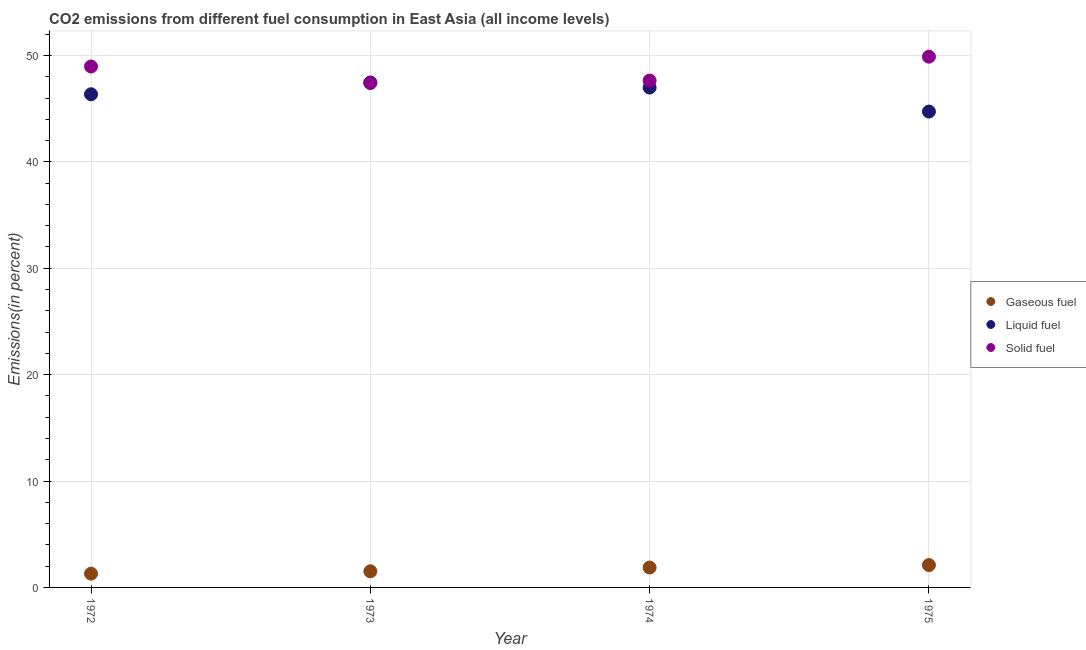How many different coloured dotlines are there?
Your response must be concise. 3. Is the number of dotlines equal to the number of legend labels?
Your answer should be compact. Yes. What is the percentage of gaseous fuel emission in 1973?
Provide a short and direct response. 1.52. Across all years, what is the maximum percentage of gaseous fuel emission?
Keep it short and to the point. 2.1. Across all years, what is the minimum percentage of liquid fuel emission?
Ensure brevity in your answer.  44.73. In which year was the percentage of liquid fuel emission maximum?
Give a very brief answer. 1973. In which year was the percentage of liquid fuel emission minimum?
Offer a terse response. 1975. What is the total percentage of gaseous fuel emission in the graph?
Offer a terse response. 6.79. What is the difference between the percentage of solid fuel emission in 1972 and that in 1974?
Your answer should be very brief. 1.33. What is the difference between the percentage of solid fuel emission in 1974 and the percentage of gaseous fuel emission in 1973?
Give a very brief answer. 46.12. What is the average percentage of gaseous fuel emission per year?
Your answer should be very brief. 1.7. In the year 1974, what is the difference between the percentage of gaseous fuel emission and percentage of liquid fuel emission?
Keep it short and to the point. -45.11. In how many years, is the percentage of gaseous fuel emission greater than 12 %?
Provide a succinct answer. 0. What is the ratio of the percentage of solid fuel emission in 1972 to that in 1975?
Ensure brevity in your answer.  0.98. What is the difference between the highest and the second highest percentage of solid fuel emission?
Offer a terse response. 0.92. What is the difference between the highest and the lowest percentage of liquid fuel emission?
Your answer should be very brief. 2.73. In how many years, is the percentage of solid fuel emission greater than the average percentage of solid fuel emission taken over all years?
Make the answer very short. 2. Does the percentage of liquid fuel emission monotonically increase over the years?
Keep it short and to the point. No. How many dotlines are there?
Your response must be concise. 3. How many years are there in the graph?
Provide a short and direct response. 4. What is the difference between two consecutive major ticks on the Y-axis?
Your response must be concise. 10. Does the graph contain any zero values?
Provide a succinct answer. No. Does the graph contain grids?
Keep it short and to the point. Yes. What is the title of the graph?
Give a very brief answer. CO2 emissions from different fuel consumption in East Asia (all income levels). Does "Transport equipments" appear as one of the legend labels in the graph?
Your response must be concise. No. What is the label or title of the X-axis?
Offer a terse response. Year. What is the label or title of the Y-axis?
Offer a terse response. Emissions(in percent). What is the Emissions(in percent) in Gaseous fuel in 1972?
Keep it short and to the point. 1.3. What is the Emissions(in percent) of Liquid fuel in 1972?
Keep it short and to the point. 46.35. What is the Emissions(in percent) of Solid fuel in 1972?
Offer a terse response. 48.96. What is the Emissions(in percent) in Gaseous fuel in 1973?
Your answer should be compact. 1.52. What is the Emissions(in percent) in Liquid fuel in 1973?
Your answer should be very brief. 47.46. What is the Emissions(in percent) in Solid fuel in 1973?
Ensure brevity in your answer.  47.41. What is the Emissions(in percent) of Gaseous fuel in 1974?
Offer a very short reply. 1.87. What is the Emissions(in percent) of Liquid fuel in 1974?
Your answer should be very brief. 46.98. What is the Emissions(in percent) in Solid fuel in 1974?
Keep it short and to the point. 47.64. What is the Emissions(in percent) of Gaseous fuel in 1975?
Your answer should be compact. 2.1. What is the Emissions(in percent) of Liquid fuel in 1975?
Give a very brief answer. 44.73. What is the Emissions(in percent) in Solid fuel in 1975?
Provide a short and direct response. 49.89. Across all years, what is the maximum Emissions(in percent) in Gaseous fuel?
Your response must be concise. 2.1. Across all years, what is the maximum Emissions(in percent) of Liquid fuel?
Your response must be concise. 47.46. Across all years, what is the maximum Emissions(in percent) in Solid fuel?
Offer a very short reply. 49.89. Across all years, what is the minimum Emissions(in percent) of Gaseous fuel?
Ensure brevity in your answer.  1.3. Across all years, what is the minimum Emissions(in percent) of Liquid fuel?
Provide a short and direct response. 44.73. Across all years, what is the minimum Emissions(in percent) of Solid fuel?
Give a very brief answer. 47.41. What is the total Emissions(in percent) of Gaseous fuel in the graph?
Make the answer very short. 6.79. What is the total Emissions(in percent) in Liquid fuel in the graph?
Ensure brevity in your answer.  185.52. What is the total Emissions(in percent) of Solid fuel in the graph?
Your response must be concise. 193.9. What is the difference between the Emissions(in percent) of Gaseous fuel in 1972 and that in 1973?
Your answer should be compact. -0.22. What is the difference between the Emissions(in percent) of Liquid fuel in 1972 and that in 1973?
Provide a succinct answer. -1.1. What is the difference between the Emissions(in percent) of Solid fuel in 1972 and that in 1973?
Give a very brief answer. 1.55. What is the difference between the Emissions(in percent) of Gaseous fuel in 1972 and that in 1974?
Offer a terse response. -0.57. What is the difference between the Emissions(in percent) of Liquid fuel in 1972 and that in 1974?
Keep it short and to the point. -0.63. What is the difference between the Emissions(in percent) in Solid fuel in 1972 and that in 1974?
Offer a very short reply. 1.33. What is the difference between the Emissions(in percent) of Gaseous fuel in 1972 and that in 1975?
Your response must be concise. -0.81. What is the difference between the Emissions(in percent) in Liquid fuel in 1972 and that in 1975?
Provide a succinct answer. 1.63. What is the difference between the Emissions(in percent) of Solid fuel in 1972 and that in 1975?
Provide a succinct answer. -0.92. What is the difference between the Emissions(in percent) in Gaseous fuel in 1973 and that in 1974?
Your answer should be compact. -0.36. What is the difference between the Emissions(in percent) of Liquid fuel in 1973 and that in 1974?
Provide a succinct answer. 0.48. What is the difference between the Emissions(in percent) in Solid fuel in 1973 and that in 1974?
Provide a short and direct response. -0.23. What is the difference between the Emissions(in percent) in Gaseous fuel in 1973 and that in 1975?
Make the answer very short. -0.59. What is the difference between the Emissions(in percent) of Liquid fuel in 1973 and that in 1975?
Make the answer very short. 2.73. What is the difference between the Emissions(in percent) of Solid fuel in 1973 and that in 1975?
Give a very brief answer. -2.48. What is the difference between the Emissions(in percent) of Gaseous fuel in 1974 and that in 1975?
Your answer should be very brief. -0.23. What is the difference between the Emissions(in percent) of Liquid fuel in 1974 and that in 1975?
Offer a very short reply. 2.26. What is the difference between the Emissions(in percent) in Solid fuel in 1974 and that in 1975?
Your answer should be very brief. -2.25. What is the difference between the Emissions(in percent) of Gaseous fuel in 1972 and the Emissions(in percent) of Liquid fuel in 1973?
Offer a very short reply. -46.16. What is the difference between the Emissions(in percent) in Gaseous fuel in 1972 and the Emissions(in percent) in Solid fuel in 1973?
Your answer should be very brief. -46.12. What is the difference between the Emissions(in percent) in Liquid fuel in 1972 and the Emissions(in percent) in Solid fuel in 1973?
Your response must be concise. -1.06. What is the difference between the Emissions(in percent) of Gaseous fuel in 1972 and the Emissions(in percent) of Liquid fuel in 1974?
Your response must be concise. -45.69. What is the difference between the Emissions(in percent) of Gaseous fuel in 1972 and the Emissions(in percent) of Solid fuel in 1974?
Keep it short and to the point. -46.34. What is the difference between the Emissions(in percent) in Liquid fuel in 1972 and the Emissions(in percent) in Solid fuel in 1974?
Keep it short and to the point. -1.28. What is the difference between the Emissions(in percent) in Gaseous fuel in 1972 and the Emissions(in percent) in Liquid fuel in 1975?
Ensure brevity in your answer.  -43.43. What is the difference between the Emissions(in percent) in Gaseous fuel in 1972 and the Emissions(in percent) in Solid fuel in 1975?
Provide a short and direct response. -48.59. What is the difference between the Emissions(in percent) in Liquid fuel in 1972 and the Emissions(in percent) in Solid fuel in 1975?
Offer a terse response. -3.53. What is the difference between the Emissions(in percent) in Gaseous fuel in 1973 and the Emissions(in percent) in Liquid fuel in 1974?
Give a very brief answer. -45.47. What is the difference between the Emissions(in percent) in Gaseous fuel in 1973 and the Emissions(in percent) in Solid fuel in 1974?
Your response must be concise. -46.12. What is the difference between the Emissions(in percent) of Liquid fuel in 1973 and the Emissions(in percent) of Solid fuel in 1974?
Keep it short and to the point. -0.18. What is the difference between the Emissions(in percent) in Gaseous fuel in 1973 and the Emissions(in percent) in Liquid fuel in 1975?
Keep it short and to the point. -43.21. What is the difference between the Emissions(in percent) of Gaseous fuel in 1973 and the Emissions(in percent) of Solid fuel in 1975?
Make the answer very short. -48.37. What is the difference between the Emissions(in percent) of Liquid fuel in 1973 and the Emissions(in percent) of Solid fuel in 1975?
Your answer should be very brief. -2.43. What is the difference between the Emissions(in percent) of Gaseous fuel in 1974 and the Emissions(in percent) of Liquid fuel in 1975?
Give a very brief answer. -42.86. What is the difference between the Emissions(in percent) in Gaseous fuel in 1974 and the Emissions(in percent) in Solid fuel in 1975?
Provide a short and direct response. -48.02. What is the difference between the Emissions(in percent) of Liquid fuel in 1974 and the Emissions(in percent) of Solid fuel in 1975?
Ensure brevity in your answer.  -2.9. What is the average Emissions(in percent) of Gaseous fuel per year?
Keep it short and to the point. 1.7. What is the average Emissions(in percent) in Liquid fuel per year?
Provide a short and direct response. 46.38. What is the average Emissions(in percent) of Solid fuel per year?
Provide a succinct answer. 48.47. In the year 1972, what is the difference between the Emissions(in percent) in Gaseous fuel and Emissions(in percent) in Liquid fuel?
Provide a succinct answer. -45.06. In the year 1972, what is the difference between the Emissions(in percent) in Gaseous fuel and Emissions(in percent) in Solid fuel?
Give a very brief answer. -47.67. In the year 1972, what is the difference between the Emissions(in percent) in Liquid fuel and Emissions(in percent) in Solid fuel?
Your response must be concise. -2.61. In the year 1973, what is the difference between the Emissions(in percent) of Gaseous fuel and Emissions(in percent) of Liquid fuel?
Keep it short and to the point. -45.94. In the year 1973, what is the difference between the Emissions(in percent) in Gaseous fuel and Emissions(in percent) in Solid fuel?
Ensure brevity in your answer.  -45.9. In the year 1973, what is the difference between the Emissions(in percent) in Liquid fuel and Emissions(in percent) in Solid fuel?
Make the answer very short. 0.05. In the year 1974, what is the difference between the Emissions(in percent) in Gaseous fuel and Emissions(in percent) in Liquid fuel?
Give a very brief answer. -45.11. In the year 1974, what is the difference between the Emissions(in percent) in Gaseous fuel and Emissions(in percent) in Solid fuel?
Provide a succinct answer. -45.77. In the year 1974, what is the difference between the Emissions(in percent) in Liquid fuel and Emissions(in percent) in Solid fuel?
Ensure brevity in your answer.  -0.66. In the year 1975, what is the difference between the Emissions(in percent) in Gaseous fuel and Emissions(in percent) in Liquid fuel?
Your answer should be compact. -42.62. In the year 1975, what is the difference between the Emissions(in percent) in Gaseous fuel and Emissions(in percent) in Solid fuel?
Your answer should be very brief. -47.78. In the year 1975, what is the difference between the Emissions(in percent) of Liquid fuel and Emissions(in percent) of Solid fuel?
Your answer should be compact. -5.16. What is the ratio of the Emissions(in percent) of Gaseous fuel in 1972 to that in 1973?
Give a very brief answer. 0.86. What is the ratio of the Emissions(in percent) in Liquid fuel in 1972 to that in 1973?
Your answer should be very brief. 0.98. What is the ratio of the Emissions(in percent) of Solid fuel in 1972 to that in 1973?
Provide a short and direct response. 1.03. What is the ratio of the Emissions(in percent) in Gaseous fuel in 1972 to that in 1974?
Offer a terse response. 0.69. What is the ratio of the Emissions(in percent) in Liquid fuel in 1972 to that in 1974?
Your answer should be compact. 0.99. What is the ratio of the Emissions(in percent) of Solid fuel in 1972 to that in 1974?
Keep it short and to the point. 1.03. What is the ratio of the Emissions(in percent) in Gaseous fuel in 1972 to that in 1975?
Provide a short and direct response. 0.62. What is the ratio of the Emissions(in percent) of Liquid fuel in 1972 to that in 1975?
Offer a very short reply. 1.04. What is the ratio of the Emissions(in percent) of Solid fuel in 1972 to that in 1975?
Your response must be concise. 0.98. What is the ratio of the Emissions(in percent) in Gaseous fuel in 1973 to that in 1974?
Provide a short and direct response. 0.81. What is the ratio of the Emissions(in percent) in Liquid fuel in 1973 to that in 1974?
Your answer should be compact. 1.01. What is the ratio of the Emissions(in percent) in Gaseous fuel in 1973 to that in 1975?
Your response must be concise. 0.72. What is the ratio of the Emissions(in percent) in Liquid fuel in 1973 to that in 1975?
Give a very brief answer. 1.06. What is the ratio of the Emissions(in percent) in Solid fuel in 1973 to that in 1975?
Give a very brief answer. 0.95. What is the ratio of the Emissions(in percent) in Gaseous fuel in 1974 to that in 1975?
Keep it short and to the point. 0.89. What is the ratio of the Emissions(in percent) in Liquid fuel in 1974 to that in 1975?
Provide a succinct answer. 1.05. What is the ratio of the Emissions(in percent) of Solid fuel in 1974 to that in 1975?
Give a very brief answer. 0.95. What is the difference between the highest and the second highest Emissions(in percent) in Gaseous fuel?
Keep it short and to the point. 0.23. What is the difference between the highest and the second highest Emissions(in percent) in Liquid fuel?
Your response must be concise. 0.48. What is the difference between the highest and the second highest Emissions(in percent) in Solid fuel?
Provide a succinct answer. 0.92. What is the difference between the highest and the lowest Emissions(in percent) of Gaseous fuel?
Give a very brief answer. 0.81. What is the difference between the highest and the lowest Emissions(in percent) of Liquid fuel?
Give a very brief answer. 2.73. What is the difference between the highest and the lowest Emissions(in percent) of Solid fuel?
Your answer should be very brief. 2.48. 